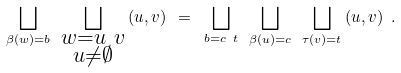<formula> <loc_0><loc_0><loc_500><loc_500>\bigsqcup _ { \beta ( w ) = b } \ \bigsqcup _ { \substack { w = u \ v \\ u \neq \emptyset } } \, ( u , v ) \ = \ \bigsqcup _ { b = c \ t } \ \bigsqcup _ { \beta ( u ) = c } \ \bigsqcup _ { \tau ( v ) = t } \, ( u , v ) \ .</formula> 